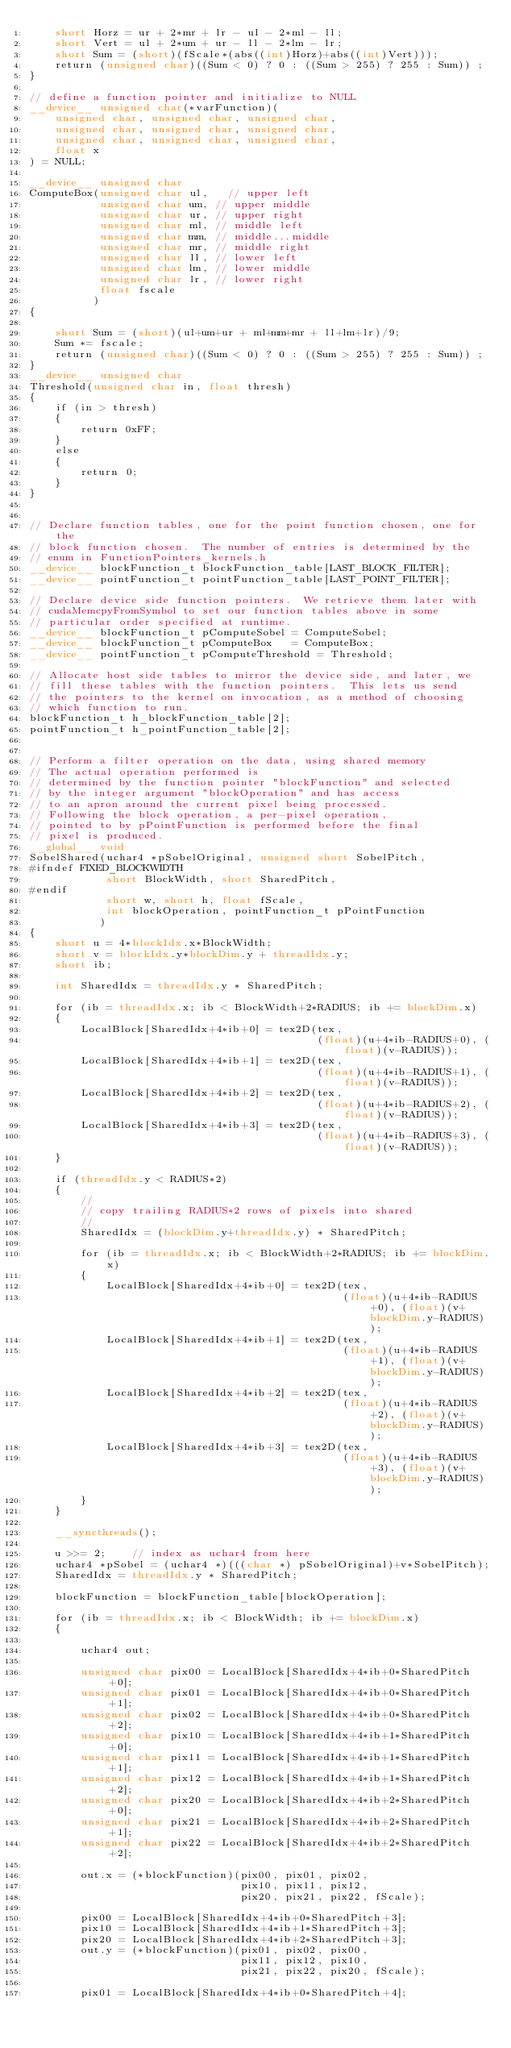<code> <loc_0><loc_0><loc_500><loc_500><_Cuda_>    short Horz = ur + 2*mr + lr - ul - 2*ml - ll;
    short Vert = ul + 2*um + ur - ll - 2*lm - lr;
    short Sum = (short)(fScale*(abs((int)Horz)+abs((int)Vert)));
    return (unsigned char)((Sum < 0) ? 0 : ((Sum > 255) ? 255 : Sum)) ;
}

// define a function pointer and initialize to NULL
__device__ unsigned char(*varFunction)(
    unsigned char, unsigned char, unsigned char,
    unsigned char, unsigned char, unsigned char,
    unsigned char, unsigned char, unsigned char,
    float x
) = NULL;

__device__ unsigned char
ComputeBox(unsigned char ul,   // upper left
           unsigned char um, // upper middle
           unsigned char ur, // upper right
           unsigned char ml, // middle left
           unsigned char mm, // middle...middle
           unsigned char mr, // middle right
           unsigned char ll, // lower left
           unsigned char lm, // lower middle
           unsigned char lr, // lower right
           float fscale
          )
{

    short Sum = (short)(ul+um+ur + ml+mm+mr + ll+lm+lr)/9;
    Sum *= fscale;
    return (unsigned char)((Sum < 0) ? 0 : ((Sum > 255) ? 255 : Sum)) ;
}
__device__ unsigned char
Threshold(unsigned char in, float thresh)
{
    if (in > thresh)
    {
        return 0xFF;
    }
    else
    {
        return 0;
    }
}


// Declare function tables, one for the point function chosen, one for the
// block function chosen.  The number of entries is determined by the
// enum in FunctionPointers_kernels.h
__device__ blockFunction_t blockFunction_table[LAST_BLOCK_FILTER];
__device__ pointFunction_t pointFunction_table[LAST_POINT_FILTER];

// Declare device side function pointers.  We retrieve them later with
// cudaMemcpyFromSymbol to set our function tables above in some
// particular order specified at runtime.
__device__ blockFunction_t pComputeSobel = ComputeSobel;
__device__ blockFunction_t pComputeBox   = ComputeBox;
__device__ pointFunction_t pComputeThreshold = Threshold;

// Allocate host side tables to mirror the device side, and later, we
// fill these tables with the function pointers.  This lets us send
// the pointers to the kernel on invocation, as a method of choosing
// which function to run.
blockFunction_t h_blockFunction_table[2];
pointFunction_t h_pointFunction_table[2];


// Perform a filter operation on the data, using shared memory
// The actual operation performed is
// determined by the function pointer "blockFunction" and selected
// by the integer argument "blockOperation" and has access
// to an apron around the current pixel being processed.
// Following the block operation, a per-pixel operation,
// pointed to by pPointFunction is performed before the final
// pixel is produced.
__global__ void
SobelShared(uchar4 *pSobelOriginal, unsigned short SobelPitch,
#ifndef FIXED_BLOCKWIDTH
            short BlockWidth, short SharedPitch,
#endif
            short w, short h, float fScale,
            int blockOperation, pointFunction_t pPointFunction
           )
{
    short u = 4*blockIdx.x*BlockWidth;
    short v = blockIdx.y*blockDim.y + threadIdx.y;
    short ib;

    int SharedIdx = threadIdx.y * SharedPitch;

    for (ib = threadIdx.x; ib < BlockWidth+2*RADIUS; ib += blockDim.x)
    {
        LocalBlock[SharedIdx+4*ib+0] = tex2D(tex,
                                             (float)(u+4*ib-RADIUS+0), (float)(v-RADIUS));
        LocalBlock[SharedIdx+4*ib+1] = tex2D(tex,
                                             (float)(u+4*ib-RADIUS+1), (float)(v-RADIUS));
        LocalBlock[SharedIdx+4*ib+2] = tex2D(tex,
                                             (float)(u+4*ib-RADIUS+2), (float)(v-RADIUS));
        LocalBlock[SharedIdx+4*ib+3] = tex2D(tex,
                                             (float)(u+4*ib-RADIUS+3), (float)(v-RADIUS));
    }

    if (threadIdx.y < RADIUS*2)
    {
        //
        // copy trailing RADIUS*2 rows of pixels into shared
        //
        SharedIdx = (blockDim.y+threadIdx.y) * SharedPitch;

        for (ib = threadIdx.x; ib < BlockWidth+2*RADIUS; ib += blockDim.x)
        {
            LocalBlock[SharedIdx+4*ib+0] = tex2D(tex,
                                                 (float)(u+4*ib-RADIUS+0), (float)(v+blockDim.y-RADIUS));
            LocalBlock[SharedIdx+4*ib+1] = tex2D(tex,
                                                 (float)(u+4*ib-RADIUS+1), (float)(v+blockDim.y-RADIUS));
            LocalBlock[SharedIdx+4*ib+2] = tex2D(tex,
                                                 (float)(u+4*ib-RADIUS+2), (float)(v+blockDim.y-RADIUS));
            LocalBlock[SharedIdx+4*ib+3] = tex2D(tex,
                                                 (float)(u+4*ib-RADIUS+3), (float)(v+blockDim.y-RADIUS));
        }
    }

    __syncthreads();

    u >>= 2;    // index as uchar4 from here
    uchar4 *pSobel = (uchar4 *)(((char *) pSobelOriginal)+v*SobelPitch);
    SharedIdx = threadIdx.y * SharedPitch;

    blockFunction = blockFunction_table[blockOperation];

    for (ib = threadIdx.x; ib < BlockWidth; ib += blockDim.x)
    {

        uchar4 out;

        unsigned char pix00 = LocalBlock[SharedIdx+4*ib+0*SharedPitch+0];
        unsigned char pix01 = LocalBlock[SharedIdx+4*ib+0*SharedPitch+1];
        unsigned char pix02 = LocalBlock[SharedIdx+4*ib+0*SharedPitch+2];
        unsigned char pix10 = LocalBlock[SharedIdx+4*ib+1*SharedPitch+0];
        unsigned char pix11 = LocalBlock[SharedIdx+4*ib+1*SharedPitch+1];
        unsigned char pix12 = LocalBlock[SharedIdx+4*ib+1*SharedPitch+2];
        unsigned char pix20 = LocalBlock[SharedIdx+4*ib+2*SharedPitch+0];
        unsigned char pix21 = LocalBlock[SharedIdx+4*ib+2*SharedPitch+1];
        unsigned char pix22 = LocalBlock[SharedIdx+4*ib+2*SharedPitch+2];

        out.x = (*blockFunction)(pix00, pix01, pix02,
                                 pix10, pix11, pix12,
                                 pix20, pix21, pix22, fScale);

        pix00 = LocalBlock[SharedIdx+4*ib+0*SharedPitch+3];
        pix10 = LocalBlock[SharedIdx+4*ib+1*SharedPitch+3];
        pix20 = LocalBlock[SharedIdx+4*ib+2*SharedPitch+3];
        out.y = (*blockFunction)(pix01, pix02, pix00,
                                 pix11, pix12, pix10,
                                 pix21, pix22, pix20, fScale);

        pix01 = LocalBlock[SharedIdx+4*ib+0*SharedPitch+4];</code> 